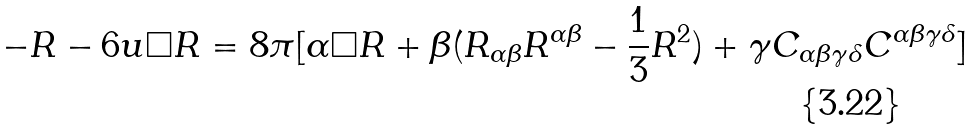<formula> <loc_0><loc_0><loc_500><loc_500>- R - 6 u \Box R = 8 \pi [ \alpha \Box R + \beta ( R _ { \alpha \beta } R ^ { \alpha \beta } - \frac { 1 } { 3 } R ^ { 2 } ) + \gamma C _ { \alpha \beta \gamma \delta } C ^ { \alpha \beta \gamma \delta } ]</formula> 